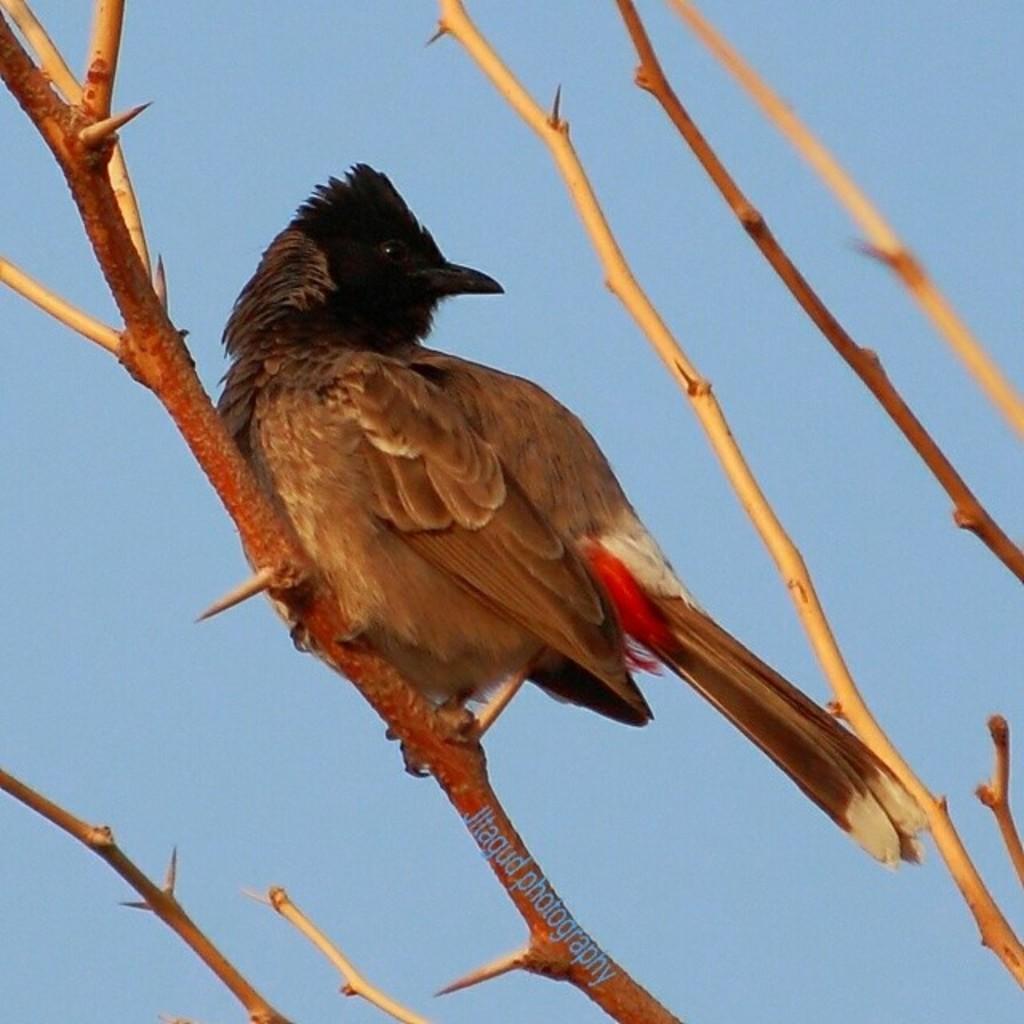Could you give a brief overview of what you see in this image? In this image we can see a bird. There are many branches of a tree in the image. We can see the sky in the image. 